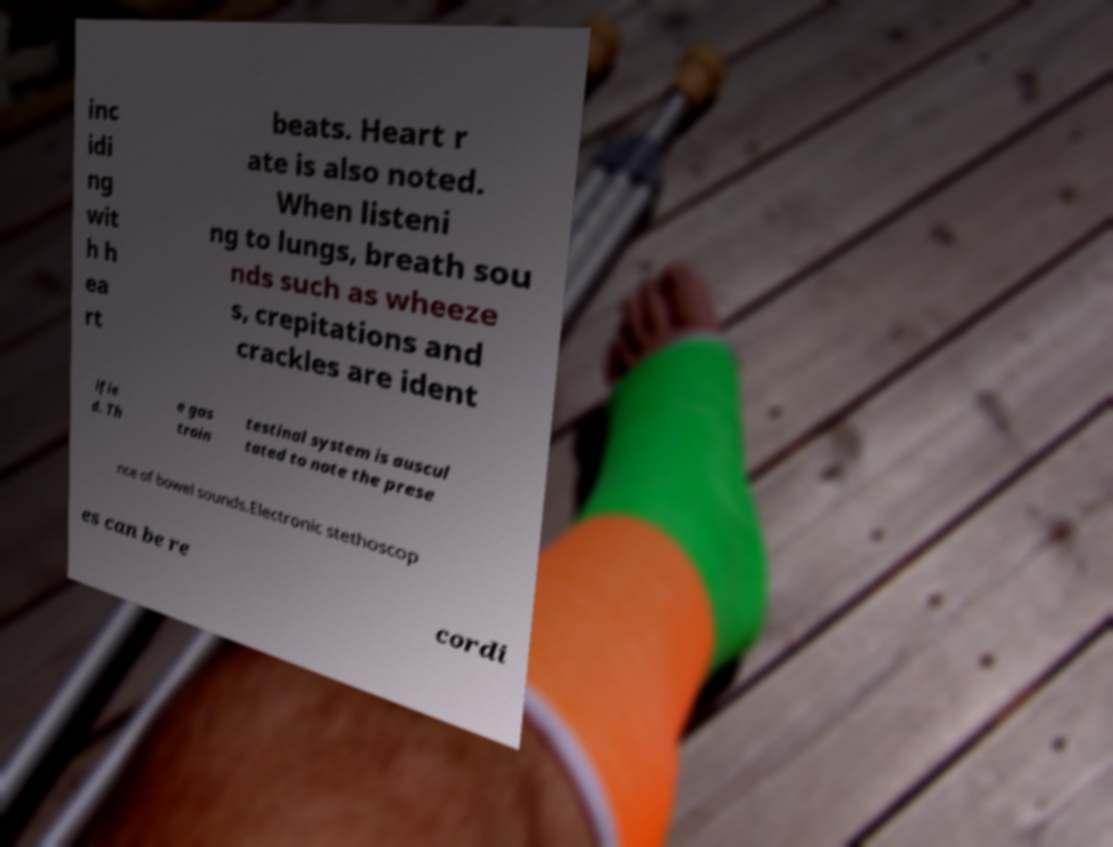I need the written content from this picture converted into text. Can you do that? inc idi ng wit h h ea rt beats. Heart r ate is also noted. When listeni ng to lungs, breath sou nds such as wheeze s, crepitations and crackles are ident ifie d. Th e gas troin testinal system is auscul tated to note the prese nce of bowel sounds.Electronic stethoscop es can be re cordi 